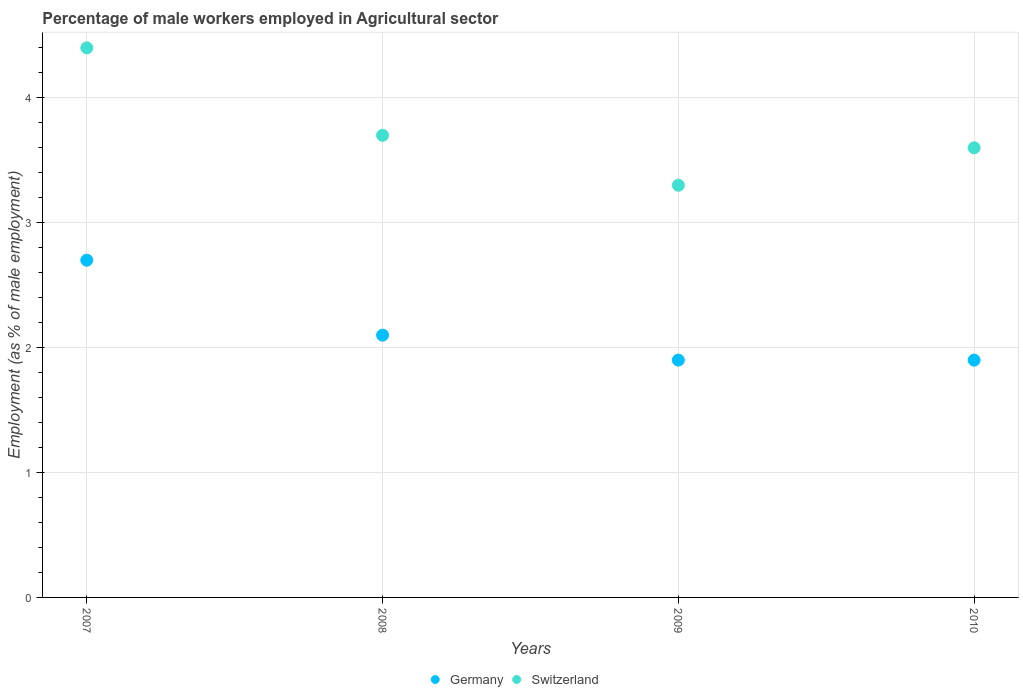What is the percentage of male workers employed in Agricultural sector in Germany in 2007?
Your answer should be compact. 2.7. Across all years, what is the maximum percentage of male workers employed in Agricultural sector in Switzerland?
Ensure brevity in your answer.  4.4. Across all years, what is the minimum percentage of male workers employed in Agricultural sector in Switzerland?
Provide a short and direct response. 3.3. What is the total percentage of male workers employed in Agricultural sector in Switzerland in the graph?
Offer a terse response. 15. What is the difference between the percentage of male workers employed in Agricultural sector in Switzerland in 2007 and that in 2009?
Your response must be concise. 1.1. What is the difference between the percentage of male workers employed in Agricultural sector in Germany in 2010 and the percentage of male workers employed in Agricultural sector in Switzerland in 2007?
Give a very brief answer. -2.5. What is the average percentage of male workers employed in Agricultural sector in Switzerland per year?
Provide a short and direct response. 3.75. In the year 2008, what is the difference between the percentage of male workers employed in Agricultural sector in Switzerland and percentage of male workers employed in Agricultural sector in Germany?
Give a very brief answer. 1.6. What is the ratio of the percentage of male workers employed in Agricultural sector in Germany in 2007 to that in 2010?
Give a very brief answer. 1.42. Is the difference between the percentage of male workers employed in Agricultural sector in Switzerland in 2009 and 2010 greater than the difference between the percentage of male workers employed in Agricultural sector in Germany in 2009 and 2010?
Your answer should be very brief. No. What is the difference between the highest and the second highest percentage of male workers employed in Agricultural sector in Switzerland?
Your answer should be compact. 0.7. What is the difference between the highest and the lowest percentage of male workers employed in Agricultural sector in Switzerland?
Your answer should be very brief. 1.1. Is the sum of the percentage of male workers employed in Agricultural sector in Germany in 2007 and 2008 greater than the maximum percentage of male workers employed in Agricultural sector in Switzerland across all years?
Keep it short and to the point. Yes. Is the percentage of male workers employed in Agricultural sector in Switzerland strictly less than the percentage of male workers employed in Agricultural sector in Germany over the years?
Offer a terse response. No. How many years are there in the graph?
Ensure brevity in your answer.  4. What is the difference between two consecutive major ticks on the Y-axis?
Ensure brevity in your answer.  1. Are the values on the major ticks of Y-axis written in scientific E-notation?
Make the answer very short. No. How are the legend labels stacked?
Your response must be concise. Horizontal. What is the title of the graph?
Your response must be concise. Percentage of male workers employed in Agricultural sector. Does "South Africa" appear as one of the legend labels in the graph?
Your answer should be compact. No. What is the label or title of the Y-axis?
Offer a terse response. Employment (as % of male employment). What is the Employment (as % of male employment) of Germany in 2007?
Make the answer very short. 2.7. What is the Employment (as % of male employment) in Switzerland in 2007?
Make the answer very short. 4.4. What is the Employment (as % of male employment) of Germany in 2008?
Your answer should be compact. 2.1. What is the Employment (as % of male employment) of Switzerland in 2008?
Give a very brief answer. 3.7. What is the Employment (as % of male employment) of Germany in 2009?
Ensure brevity in your answer.  1.9. What is the Employment (as % of male employment) in Switzerland in 2009?
Your response must be concise. 3.3. What is the Employment (as % of male employment) of Germany in 2010?
Give a very brief answer. 1.9. What is the Employment (as % of male employment) of Switzerland in 2010?
Ensure brevity in your answer.  3.6. Across all years, what is the maximum Employment (as % of male employment) in Germany?
Make the answer very short. 2.7. Across all years, what is the maximum Employment (as % of male employment) in Switzerland?
Provide a short and direct response. 4.4. Across all years, what is the minimum Employment (as % of male employment) of Germany?
Offer a very short reply. 1.9. Across all years, what is the minimum Employment (as % of male employment) in Switzerland?
Offer a very short reply. 3.3. What is the total Employment (as % of male employment) in Switzerland in the graph?
Offer a terse response. 15. What is the difference between the Employment (as % of male employment) of Switzerland in 2007 and that in 2008?
Ensure brevity in your answer.  0.7. What is the difference between the Employment (as % of male employment) in Switzerland in 2007 and that in 2009?
Offer a very short reply. 1.1. What is the difference between the Employment (as % of male employment) of Switzerland in 2007 and that in 2010?
Provide a short and direct response. 0.8. What is the difference between the Employment (as % of male employment) of Germany in 2008 and that in 2010?
Offer a very short reply. 0.2. What is the difference between the Employment (as % of male employment) of Germany in 2009 and that in 2010?
Your response must be concise. 0. What is the difference between the Employment (as % of male employment) of Switzerland in 2009 and that in 2010?
Offer a terse response. -0.3. What is the difference between the Employment (as % of male employment) in Germany in 2007 and the Employment (as % of male employment) in Switzerland in 2008?
Your response must be concise. -1. What is the difference between the Employment (as % of male employment) in Germany in 2007 and the Employment (as % of male employment) in Switzerland in 2009?
Give a very brief answer. -0.6. What is the difference between the Employment (as % of male employment) of Germany in 2009 and the Employment (as % of male employment) of Switzerland in 2010?
Give a very brief answer. -1.7. What is the average Employment (as % of male employment) of Germany per year?
Make the answer very short. 2.15. What is the average Employment (as % of male employment) of Switzerland per year?
Make the answer very short. 3.75. In the year 2008, what is the difference between the Employment (as % of male employment) of Germany and Employment (as % of male employment) of Switzerland?
Make the answer very short. -1.6. In the year 2010, what is the difference between the Employment (as % of male employment) of Germany and Employment (as % of male employment) of Switzerland?
Provide a short and direct response. -1.7. What is the ratio of the Employment (as % of male employment) in Switzerland in 2007 to that in 2008?
Offer a terse response. 1.19. What is the ratio of the Employment (as % of male employment) in Germany in 2007 to that in 2009?
Keep it short and to the point. 1.42. What is the ratio of the Employment (as % of male employment) of Switzerland in 2007 to that in 2009?
Ensure brevity in your answer.  1.33. What is the ratio of the Employment (as % of male employment) of Germany in 2007 to that in 2010?
Your response must be concise. 1.42. What is the ratio of the Employment (as % of male employment) of Switzerland in 2007 to that in 2010?
Provide a succinct answer. 1.22. What is the ratio of the Employment (as % of male employment) of Germany in 2008 to that in 2009?
Provide a short and direct response. 1.11. What is the ratio of the Employment (as % of male employment) in Switzerland in 2008 to that in 2009?
Offer a terse response. 1.12. What is the ratio of the Employment (as % of male employment) of Germany in 2008 to that in 2010?
Offer a terse response. 1.11. What is the ratio of the Employment (as % of male employment) in Switzerland in 2008 to that in 2010?
Keep it short and to the point. 1.03. What is the difference between the highest and the lowest Employment (as % of male employment) of Switzerland?
Your answer should be very brief. 1.1. 